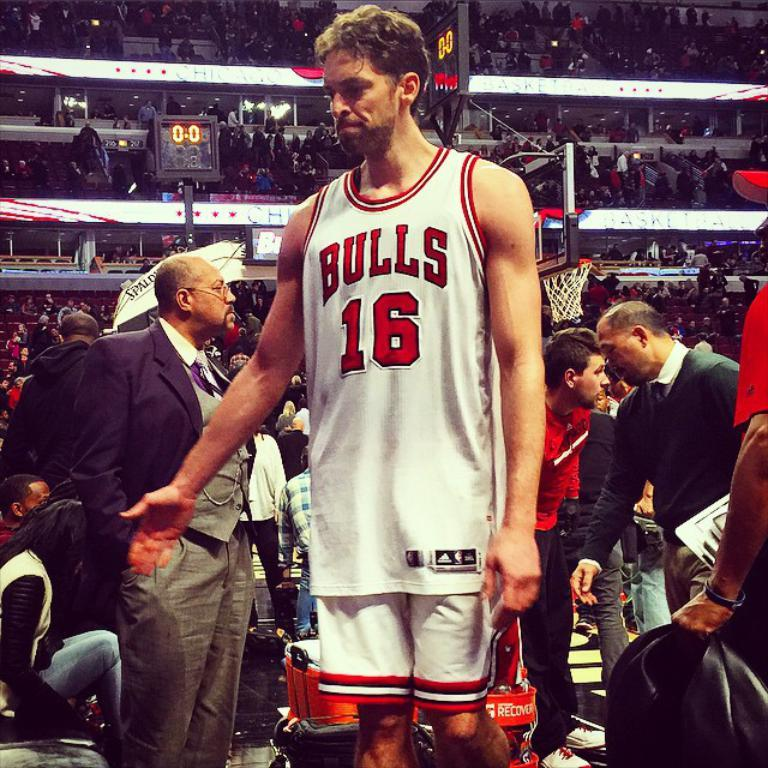<image>
Relay a brief, clear account of the picture shown. A man wearing a Bulls jersey stands in a basketball arena. 